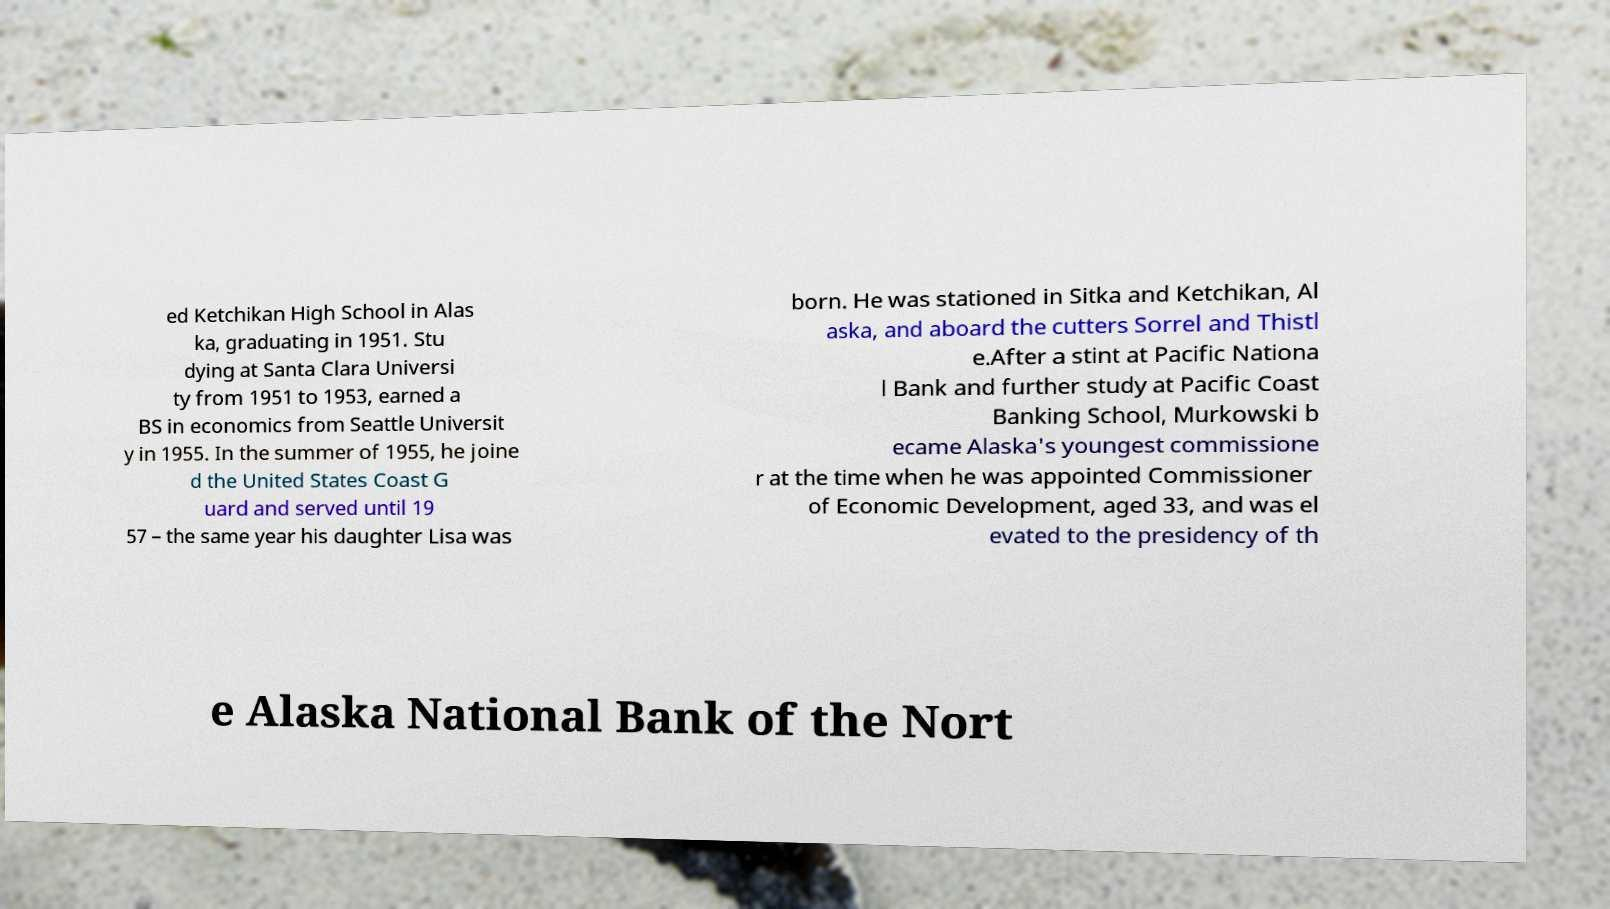Can you read and provide the text displayed in the image?This photo seems to have some interesting text. Can you extract and type it out for me? ed Ketchikan High School in Alas ka, graduating in 1951. Stu dying at Santa Clara Universi ty from 1951 to 1953, earned a BS in economics from Seattle Universit y in 1955. In the summer of 1955, he joine d the United States Coast G uard and served until 19 57 – the same year his daughter Lisa was born. He was stationed in Sitka and Ketchikan, Al aska, and aboard the cutters Sorrel and Thistl e.After a stint at Pacific Nationa l Bank and further study at Pacific Coast Banking School, Murkowski b ecame Alaska's youngest commissione r at the time when he was appointed Commissioner of Economic Development, aged 33, and was el evated to the presidency of th e Alaska National Bank of the Nort 